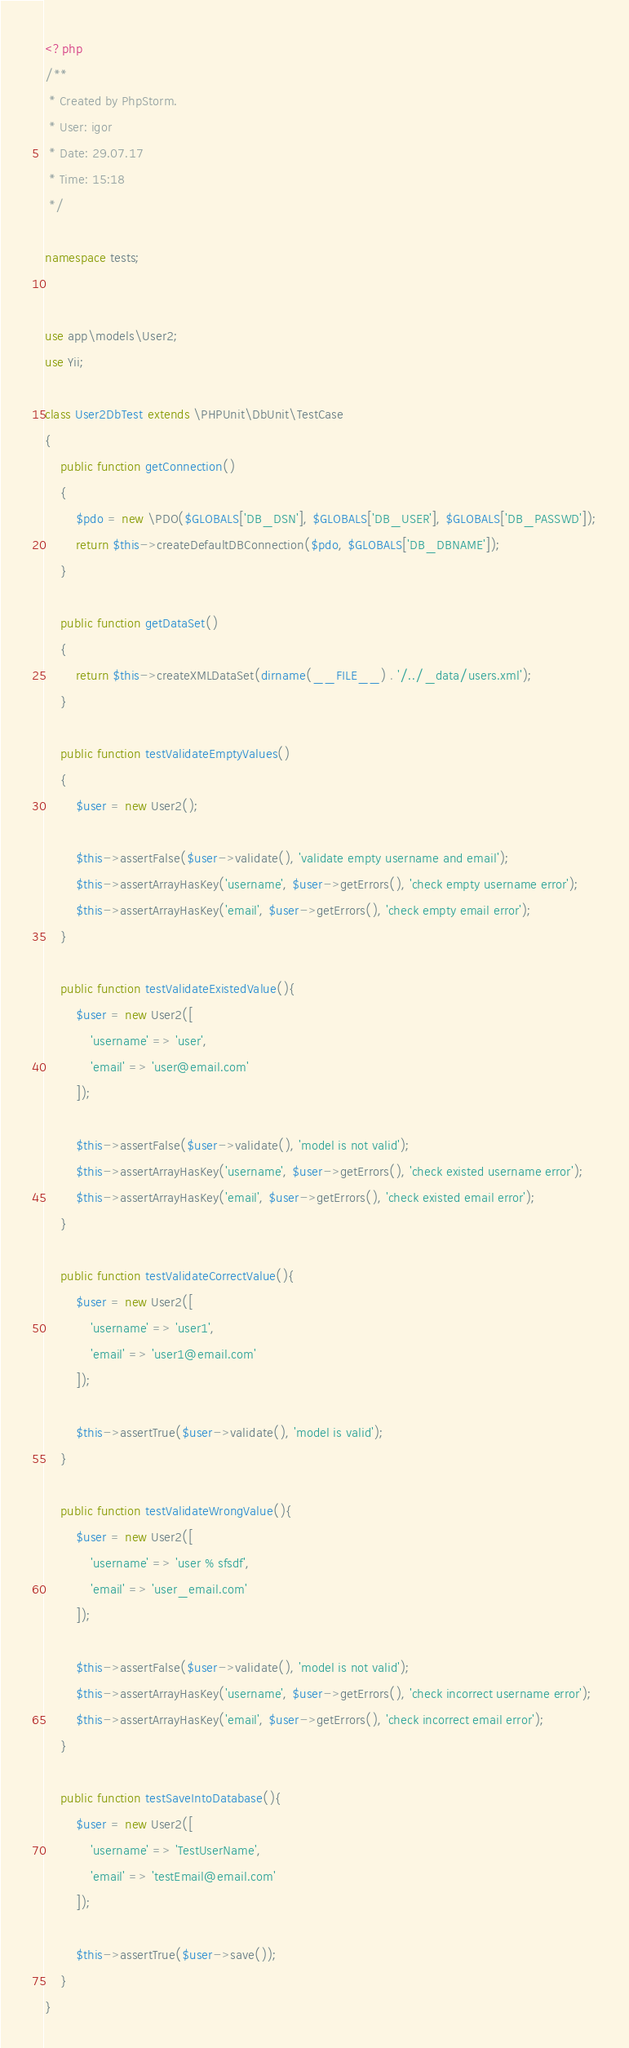Convert code to text. <code><loc_0><loc_0><loc_500><loc_500><_PHP_><?php
/**
 * Created by PhpStorm.
 * User: igor
 * Date: 29.07.17
 * Time: 15:18
 */

namespace tests;


use app\models\User2;
use Yii;

class User2DbTest extends \PHPUnit\DbUnit\TestCase
{
    public function getConnection()
    {
        $pdo = new \PDO($GLOBALS['DB_DSN'], $GLOBALS['DB_USER'], $GLOBALS['DB_PASSWD']);
        return $this->createDefaultDBConnection($pdo, $GLOBALS['DB_DBNAME']);
    }

    public function getDataSet()
    {
        return $this->createXMLDataSet(dirname(__FILE__) . '/../_data/users.xml');
    }

    public function testValidateEmptyValues()
    {
        $user = new User2();

        $this->assertFalse($user->validate(), 'validate empty username and email');
        $this->assertArrayHasKey('username', $user->getErrors(), 'check empty username error');
        $this->assertArrayHasKey('email', $user->getErrors(), 'check empty email error');
    }

    public function testValidateExistedValue(){
        $user = new User2([
            'username' => 'user',
            'email' => 'user@email.com'
        ]);

        $this->assertFalse($user->validate(), 'model is not valid');
        $this->assertArrayHasKey('username', $user->getErrors(), 'check existed username error');
        $this->assertArrayHasKey('email', $user->getErrors(), 'check existed email error');
    }

    public function testValidateCorrectValue(){
        $user = new User2([
            'username' => 'user1',
            'email' => 'user1@email.com'
        ]);

        $this->assertTrue($user->validate(), 'model is valid');
    }

    public function testValidateWrongValue(){
        $user = new User2([
            'username' => 'user % sfsdf',
            'email' => 'user_email.com'
        ]);

        $this->assertFalse($user->validate(), 'model is not valid');
        $this->assertArrayHasKey('username', $user->getErrors(), 'check incorrect username error');
        $this->assertArrayHasKey('email', $user->getErrors(), 'check incorrect email error');
    }

    public function testSaveIntoDatabase(){
        $user = new User2([
            'username' => 'TestUserName',
            'email' => 'testEmail@email.com'
        ]);

        $this->assertTrue($user->save());
    }
}</code> 